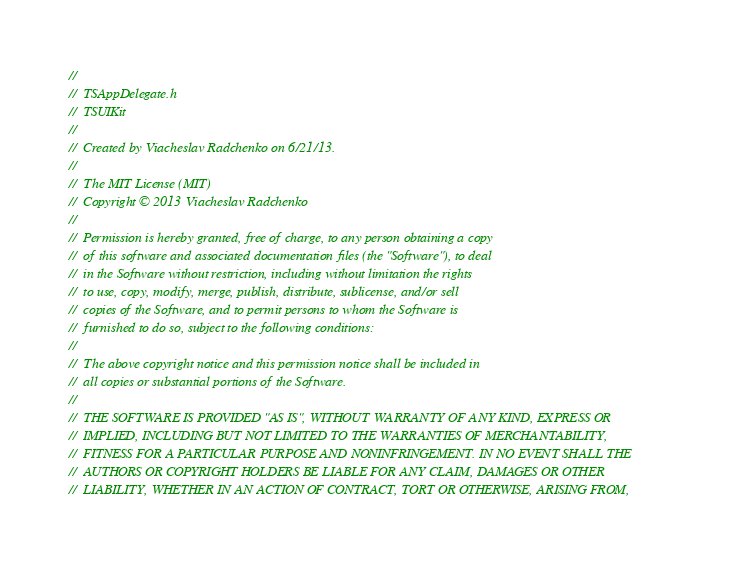Convert code to text. <code><loc_0><loc_0><loc_500><loc_500><_C_>//
//  TSAppDelegate.h
//  TSUIKit
//
//  Created by Viacheslav Radchenko on 6/21/13.
//
//  The MIT License (MIT)
//  Copyright © 2013 Viacheslav Radchenko
//
//  Permission is hereby granted, free of charge, to any person obtaining a copy
//  of this software and associated documentation files (the "Software"), to deal
//  in the Software without restriction, including without limitation the rights
//  to use, copy, modify, merge, publish, distribute, sublicense, and/or sell
//  copies of the Software, and to permit persons to whom the Software is
//  furnished to do so, subject to the following conditions:
//
//  The above copyright notice and this permission notice shall be included in
//  all copies or substantial portions of the Software.
//
//  THE SOFTWARE IS PROVIDED "AS IS", WITHOUT WARRANTY OF ANY KIND, EXPRESS OR
//  IMPLIED, INCLUDING BUT NOT LIMITED TO THE WARRANTIES OF MERCHANTABILITY,
//  FITNESS FOR A PARTICULAR PURPOSE AND NONINFRINGEMENT. IN NO EVENT SHALL THE
//  AUTHORS OR COPYRIGHT HOLDERS BE LIABLE FOR ANY CLAIM, DAMAGES OR OTHER
//  LIABILITY, WHETHER IN AN ACTION OF CONTRACT, TORT OR OTHERWISE, ARISING FROM,</code> 